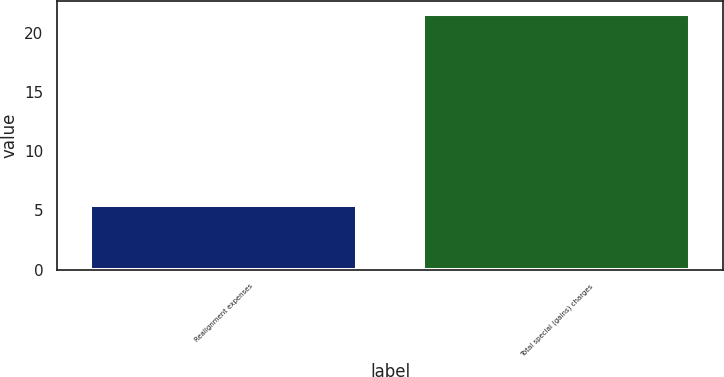Convert chart to OTSL. <chart><loc_0><loc_0><loc_500><loc_500><bar_chart><fcel>Realignment expenses<fcel>Total special (gains) charges<nl><fcel>5.5<fcel>21.6<nl></chart> 